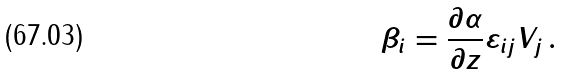<formula> <loc_0><loc_0><loc_500><loc_500>\beta _ { i } = \frac { \partial \alpha } { \partial z } \varepsilon _ { i j } V _ { j } \, .</formula> 